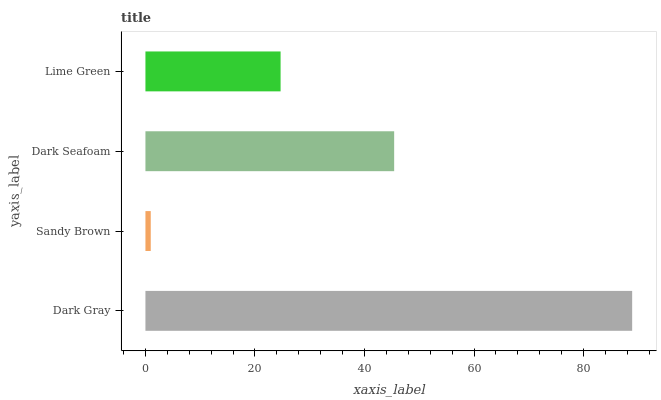Is Sandy Brown the minimum?
Answer yes or no. Yes. Is Dark Gray the maximum?
Answer yes or no. Yes. Is Dark Seafoam the minimum?
Answer yes or no. No. Is Dark Seafoam the maximum?
Answer yes or no. No. Is Dark Seafoam greater than Sandy Brown?
Answer yes or no. Yes. Is Sandy Brown less than Dark Seafoam?
Answer yes or no. Yes. Is Sandy Brown greater than Dark Seafoam?
Answer yes or no. No. Is Dark Seafoam less than Sandy Brown?
Answer yes or no. No. Is Dark Seafoam the high median?
Answer yes or no. Yes. Is Lime Green the low median?
Answer yes or no. Yes. Is Sandy Brown the high median?
Answer yes or no. No. Is Dark Seafoam the low median?
Answer yes or no. No. 